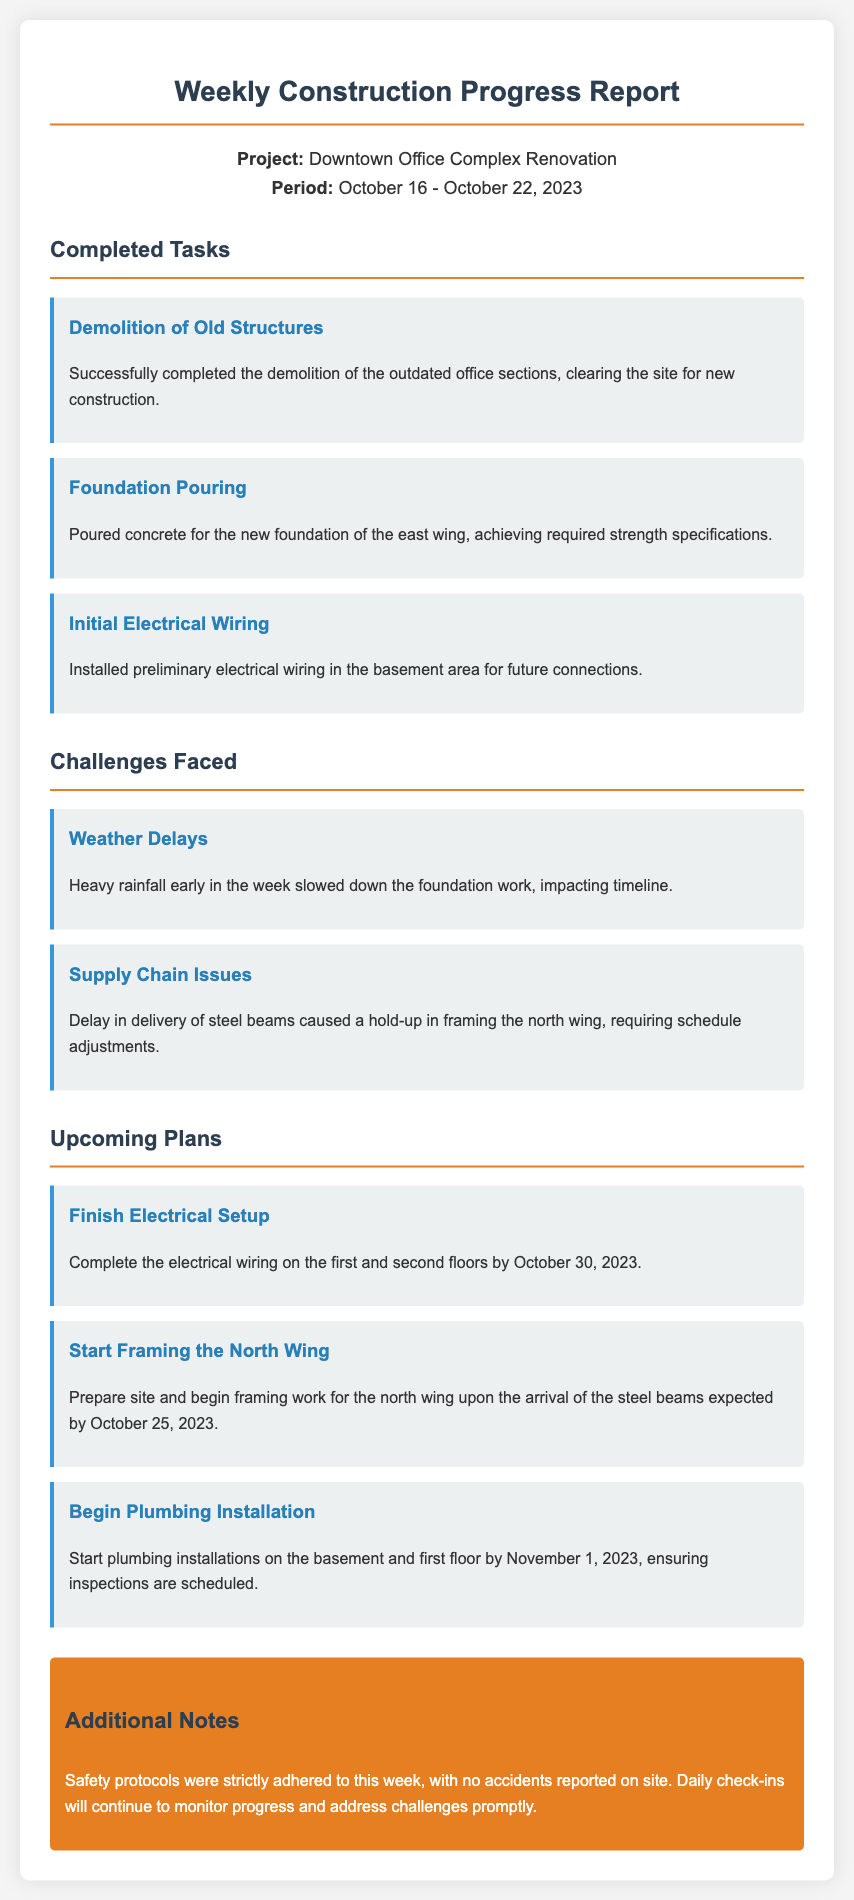What is the project name? The project name is mentioned at the beginning of the report under project info.
Answer: Downtown Office Complex Renovation What dates does the report cover? The report specifies the period it covers in the project info section.
Answer: October 16 - October 22, 2023 How many completed tasks are listed? The report contains a section on completed tasks with three listed items.
Answer: 3 What challenge involved weather? The report highlights weather-related issues in the challenges section.
Answer: Weather Delays What is the deadline for finishing electrical setup? The upcoming plans section specifies the completion date for electrical setup.
Answer: October 30, 2023 What is the task involving plumbing installations? The upcoming plans list a specific task for plumbing installations in the future.
Answer: Begin Plumbing Installation What specific challenge was mentioned concerning materials? The report outlines a challenge related to supply chain issues.
Answer: Supply Chain Issues When are the steel beams expected to arrive? This information is provided in the upcoming plans regarding the start of framing.
Answer: October 25, 2023 